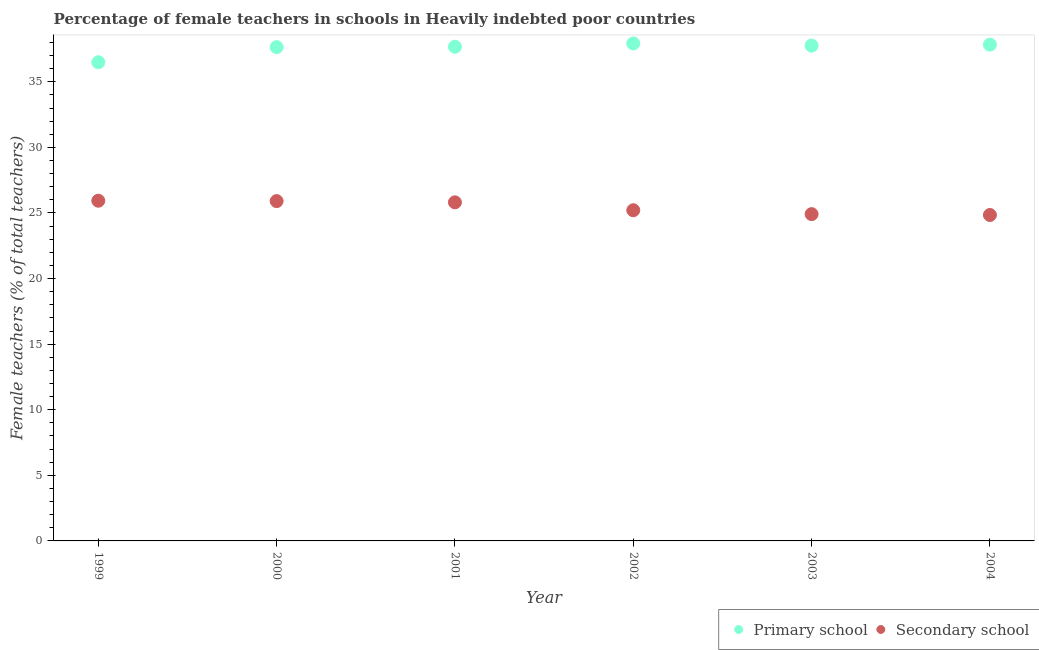What is the percentage of female teachers in primary schools in 2003?
Offer a terse response. 37.76. Across all years, what is the maximum percentage of female teachers in primary schools?
Ensure brevity in your answer.  37.92. Across all years, what is the minimum percentage of female teachers in secondary schools?
Offer a very short reply. 24.85. In which year was the percentage of female teachers in secondary schools minimum?
Provide a short and direct response. 2004. What is the total percentage of female teachers in secondary schools in the graph?
Offer a terse response. 152.62. What is the difference between the percentage of female teachers in secondary schools in 1999 and that in 2002?
Make the answer very short. 0.73. What is the difference between the percentage of female teachers in primary schools in 1999 and the percentage of female teachers in secondary schools in 2000?
Provide a succinct answer. 10.58. What is the average percentage of female teachers in primary schools per year?
Give a very brief answer. 37.55. In the year 2002, what is the difference between the percentage of female teachers in secondary schools and percentage of female teachers in primary schools?
Provide a short and direct response. -12.71. What is the ratio of the percentage of female teachers in primary schools in 2000 to that in 2004?
Ensure brevity in your answer.  0.99. Is the difference between the percentage of female teachers in primary schools in 1999 and 2001 greater than the difference between the percentage of female teachers in secondary schools in 1999 and 2001?
Your response must be concise. No. What is the difference between the highest and the second highest percentage of female teachers in secondary schools?
Make the answer very short. 0.03. What is the difference between the highest and the lowest percentage of female teachers in secondary schools?
Provide a succinct answer. 1.09. Is the sum of the percentage of female teachers in primary schools in 2002 and 2003 greater than the maximum percentage of female teachers in secondary schools across all years?
Your response must be concise. Yes. Does the percentage of female teachers in secondary schools monotonically increase over the years?
Provide a succinct answer. No. Is the percentage of female teachers in primary schools strictly greater than the percentage of female teachers in secondary schools over the years?
Provide a succinct answer. Yes. How many dotlines are there?
Keep it short and to the point. 2. How many years are there in the graph?
Your answer should be compact. 6. What is the difference between two consecutive major ticks on the Y-axis?
Your answer should be compact. 5. Does the graph contain any zero values?
Provide a short and direct response. No. Does the graph contain grids?
Ensure brevity in your answer.  No. Where does the legend appear in the graph?
Give a very brief answer. Bottom right. How many legend labels are there?
Provide a short and direct response. 2. What is the title of the graph?
Your answer should be very brief. Percentage of female teachers in schools in Heavily indebted poor countries. What is the label or title of the Y-axis?
Your answer should be very brief. Female teachers (% of total teachers). What is the Female teachers (% of total teachers) of Primary school in 1999?
Make the answer very short. 36.49. What is the Female teachers (% of total teachers) of Secondary school in 1999?
Provide a succinct answer. 25.93. What is the Female teachers (% of total teachers) of Primary school in 2000?
Your answer should be compact. 37.64. What is the Female teachers (% of total teachers) in Secondary school in 2000?
Provide a succinct answer. 25.9. What is the Female teachers (% of total teachers) of Primary school in 2001?
Offer a terse response. 37.67. What is the Female teachers (% of total teachers) in Secondary school in 2001?
Keep it short and to the point. 25.81. What is the Female teachers (% of total teachers) of Primary school in 2002?
Keep it short and to the point. 37.92. What is the Female teachers (% of total teachers) in Secondary school in 2002?
Provide a short and direct response. 25.21. What is the Female teachers (% of total teachers) of Primary school in 2003?
Give a very brief answer. 37.76. What is the Female teachers (% of total teachers) in Secondary school in 2003?
Keep it short and to the point. 24.91. What is the Female teachers (% of total teachers) in Primary school in 2004?
Offer a terse response. 37.83. What is the Female teachers (% of total teachers) of Secondary school in 2004?
Offer a very short reply. 24.85. Across all years, what is the maximum Female teachers (% of total teachers) in Primary school?
Keep it short and to the point. 37.92. Across all years, what is the maximum Female teachers (% of total teachers) in Secondary school?
Give a very brief answer. 25.93. Across all years, what is the minimum Female teachers (% of total teachers) of Primary school?
Offer a terse response. 36.49. Across all years, what is the minimum Female teachers (% of total teachers) in Secondary school?
Keep it short and to the point. 24.85. What is the total Female teachers (% of total teachers) in Primary school in the graph?
Your answer should be very brief. 225.32. What is the total Female teachers (% of total teachers) in Secondary school in the graph?
Provide a succinct answer. 152.62. What is the difference between the Female teachers (% of total teachers) in Primary school in 1999 and that in 2000?
Offer a terse response. -1.15. What is the difference between the Female teachers (% of total teachers) in Secondary school in 1999 and that in 2000?
Make the answer very short. 0.03. What is the difference between the Female teachers (% of total teachers) in Primary school in 1999 and that in 2001?
Ensure brevity in your answer.  -1.18. What is the difference between the Female teachers (% of total teachers) of Secondary school in 1999 and that in 2001?
Provide a succinct answer. 0.12. What is the difference between the Female teachers (% of total teachers) of Primary school in 1999 and that in 2002?
Offer a very short reply. -1.43. What is the difference between the Female teachers (% of total teachers) of Secondary school in 1999 and that in 2002?
Provide a succinct answer. 0.73. What is the difference between the Female teachers (% of total teachers) in Primary school in 1999 and that in 2003?
Your response must be concise. -1.27. What is the difference between the Female teachers (% of total teachers) of Secondary school in 1999 and that in 2003?
Provide a succinct answer. 1.02. What is the difference between the Female teachers (% of total teachers) in Primary school in 1999 and that in 2004?
Your answer should be compact. -1.34. What is the difference between the Female teachers (% of total teachers) in Secondary school in 1999 and that in 2004?
Give a very brief answer. 1.09. What is the difference between the Female teachers (% of total teachers) of Primary school in 2000 and that in 2001?
Your answer should be very brief. -0.03. What is the difference between the Female teachers (% of total teachers) of Secondary school in 2000 and that in 2001?
Provide a succinct answer. 0.09. What is the difference between the Female teachers (% of total teachers) of Primary school in 2000 and that in 2002?
Make the answer very short. -0.28. What is the difference between the Female teachers (% of total teachers) in Secondary school in 2000 and that in 2002?
Make the answer very short. 0.7. What is the difference between the Female teachers (% of total teachers) in Primary school in 2000 and that in 2003?
Give a very brief answer. -0.12. What is the difference between the Female teachers (% of total teachers) in Secondary school in 2000 and that in 2003?
Your response must be concise. 0.99. What is the difference between the Female teachers (% of total teachers) in Primary school in 2000 and that in 2004?
Provide a short and direct response. -0.19. What is the difference between the Female teachers (% of total teachers) in Secondary school in 2000 and that in 2004?
Make the answer very short. 1.06. What is the difference between the Female teachers (% of total teachers) of Primary school in 2001 and that in 2002?
Offer a very short reply. -0.25. What is the difference between the Female teachers (% of total teachers) of Secondary school in 2001 and that in 2002?
Ensure brevity in your answer.  0.6. What is the difference between the Female teachers (% of total teachers) in Primary school in 2001 and that in 2003?
Keep it short and to the point. -0.09. What is the difference between the Female teachers (% of total teachers) of Secondary school in 2001 and that in 2003?
Your answer should be very brief. 0.9. What is the difference between the Female teachers (% of total teachers) in Primary school in 2001 and that in 2004?
Your answer should be compact. -0.16. What is the difference between the Female teachers (% of total teachers) of Primary school in 2002 and that in 2003?
Give a very brief answer. 0.16. What is the difference between the Female teachers (% of total teachers) in Secondary school in 2002 and that in 2003?
Make the answer very short. 0.3. What is the difference between the Female teachers (% of total teachers) in Primary school in 2002 and that in 2004?
Give a very brief answer. 0.09. What is the difference between the Female teachers (% of total teachers) of Secondary school in 2002 and that in 2004?
Keep it short and to the point. 0.36. What is the difference between the Female teachers (% of total teachers) in Primary school in 2003 and that in 2004?
Keep it short and to the point. -0.08. What is the difference between the Female teachers (% of total teachers) of Secondary school in 2003 and that in 2004?
Provide a succinct answer. 0.07. What is the difference between the Female teachers (% of total teachers) of Primary school in 1999 and the Female teachers (% of total teachers) of Secondary school in 2000?
Provide a short and direct response. 10.58. What is the difference between the Female teachers (% of total teachers) of Primary school in 1999 and the Female teachers (% of total teachers) of Secondary school in 2001?
Offer a very short reply. 10.68. What is the difference between the Female teachers (% of total teachers) in Primary school in 1999 and the Female teachers (% of total teachers) in Secondary school in 2002?
Provide a short and direct response. 11.28. What is the difference between the Female teachers (% of total teachers) of Primary school in 1999 and the Female teachers (% of total teachers) of Secondary school in 2003?
Make the answer very short. 11.58. What is the difference between the Female teachers (% of total teachers) in Primary school in 1999 and the Female teachers (% of total teachers) in Secondary school in 2004?
Your response must be concise. 11.64. What is the difference between the Female teachers (% of total teachers) of Primary school in 2000 and the Female teachers (% of total teachers) of Secondary school in 2001?
Make the answer very short. 11.83. What is the difference between the Female teachers (% of total teachers) in Primary school in 2000 and the Female teachers (% of total teachers) in Secondary school in 2002?
Provide a short and direct response. 12.43. What is the difference between the Female teachers (% of total teachers) in Primary school in 2000 and the Female teachers (% of total teachers) in Secondary school in 2003?
Provide a short and direct response. 12.73. What is the difference between the Female teachers (% of total teachers) in Primary school in 2000 and the Female teachers (% of total teachers) in Secondary school in 2004?
Your answer should be very brief. 12.8. What is the difference between the Female teachers (% of total teachers) of Primary school in 2001 and the Female teachers (% of total teachers) of Secondary school in 2002?
Make the answer very short. 12.46. What is the difference between the Female teachers (% of total teachers) in Primary school in 2001 and the Female teachers (% of total teachers) in Secondary school in 2003?
Offer a terse response. 12.76. What is the difference between the Female teachers (% of total teachers) in Primary school in 2001 and the Female teachers (% of total teachers) in Secondary school in 2004?
Provide a short and direct response. 12.82. What is the difference between the Female teachers (% of total teachers) in Primary school in 2002 and the Female teachers (% of total teachers) in Secondary school in 2003?
Your answer should be compact. 13.01. What is the difference between the Female teachers (% of total teachers) of Primary school in 2002 and the Female teachers (% of total teachers) of Secondary school in 2004?
Your answer should be compact. 13.08. What is the difference between the Female teachers (% of total teachers) of Primary school in 2003 and the Female teachers (% of total teachers) of Secondary school in 2004?
Make the answer very short. 12.91. What is the average Female teachers (% of total teachers) in Primary school per year?
Your answer should be very brief. 37.55. What is the average Female teachers (% of total teachers) in Secondary school per year?
Your answer should be compact. 25.44. In the year 1999, what is the difference between the Female teachers (% of total teachers) in Primary school and Female teachers (% of total teachers) in Secondary school?
Your answer should be compact. 10.55. In the year 2000, what is the difference between the Female teachers (% of total teachers) in Primary school and Female teachers (% of total teachers) in Secondary school?
Keep it short and to the point. 11.74. In the year 2001, what is the difference between the Female teachers (% of total teachers) of Primary school and Female teachers (% of total teachers) of Secondary school?
Make the answer very short. 11.86. In the year 2002, what is the difference between the Female teachers (% of total teachers) in Primary school and Female teachers (% of total teachers) in Secondary school?
Provide a succinct answer. 12.71. In the year 2003, what is the difference between the Female teachers (% of total teachers) of Primary school and Female teachers (% of total teachers) of Secondary school?
Offer a terse response. 12.85. In the year 2004, what is the difference between the Female teachers (% of total teachers) of Primary school and Female teachers (% of total teachers) of Secondary school?
Your answer should be compact. 12.99. What is the ratio of the Female teachers (% of total teachers) of Primary school in 1999 to that in 2000?
Your answer should be very brief. 0.97. What is the ratio of the Female teachers (% of total teachers) of Secondary school in 1999 to that in 2000?
Give a very brief answer. 1. What is the ratio of the Female teachers (% of total teachers) of Primary school in 1999 to that in 2001?
Offer a terse response. 0.97. What is the ratio of the Female teachers (% of total teachers) of Primary school in 1999 to that in 2002?
Provide a short and direct response. 0.96. What is the ratio of the Female teachers (% of total teachers) of Secondary school in 1999 to that in 2002?
Ensure brevity in your answer.  1.03. What is the ratio of the Female teachers (% of total teachers) of Primary school in 1999 to that in 2003?
Keep it short and to the point. 0.97. What is the ratio of the Female teachers (% of total teachers) in Secondary school in 1999 to that in 2003?
Give a very brief answer. 1.04. What is the ratio of the Female teachers (% of total teachers) in Primary school in 1999 to that in 2004?
Make the answer very short. 0.96. What is the ratio of the Female teachers (% of total teachers) of Secondary school in 1999 to that in 2004?
Your response must be concise. 1.04. What is the ratio of the Female teachers (% of total teachers) in Primary school in 2000 to that in 2002?
Provide a succinct answer. 0.99. What is the ratio of the Female teachers (% of total teachers) in Secondary school in 2000 to that in 2002?
Offer a very short reply. 1.03. What is the ratio of the Female teachers (% of total teachers) of Secondary school in 2000 to that in 2003?
Make the answer very short. 1.04. What is the ratio of the Female teachers (% of total teachers) of Secondary school in 2000 to that in 2004?
Provide a succinct answer. 1.04. What is the ratio of the Female teachers (% of total teachers) of Secondary school in 2001 to that in 2002?
Provide a succinct answer. 1.02. What is the ratio of the Female teachers (% of total teachers) of Secondary school in 2001 to that in 2003?
Provide a succinct answer. 1.04. What is the ratio of the Female teachers (% of total teachers) of Primary school in 2001 to that in 2004?
Your response must be concise. 1. What is the ratio of the Female teachers (% of total teachers) in Secondary school in 2001 to that in 2004?
Your answer should be very brief. 1.04. What is the ratio of the Female teachers (% of total teachers) of Primary school in 2002 to that in 2003?
Provide a succinct answer. 1. What is the ratio of the Female teachers (% of total teachers) of Secondary school in 2002 to that in 2003?
Offer a very short reply. 1.01. What is the ratio of the Female teachers (% of total teachers) in Primary school in 2002 to that in 2004?
Make the answer very short. 1. What is the ratio of the Female teachers (% of total teachers) in Secondary school in 2002 to that in 2004?
Provide a short and direct response. 1.01. What is the ratio of the Female teachers (% of total teachers) of Secondary school in 2003 to that in 2004?
Make the answer very short. 1. What is the difference between the highest and the second highest Female teachers (% of total teachers) of Primary school?
Offer a terse response. 0.09. What is the difference between the highest and the second highest Female teachers (% of total teachers) of Secondary school?
Provide a succinct answer. 0.03. What is the difference between the highest and the lowest Female teachers (% of total teachers) of Primary school?
Your response must be concise. 1.43. What is the difference between the highest and the lowest Female teachers (% of total teachers) in Secondary school?
Your answer should be compact. 1.09. 